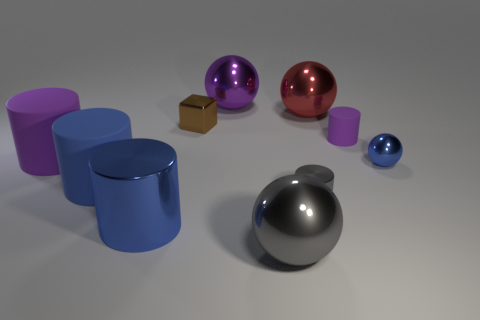Subtract all gray cylinders. How many cylinders are left? 4 Subtract all large shiny cylinders. How many cylinders are left? 4 Subtract all red cylinders. Subtract all red blocks. How many cylinders are left? 5 Subtract all cubes. How many objects are left? 9 Subtract all big gray metal spheres. Subtract all large gray objects. How many objects are left? 8 Add 2 purple objects. How many purple objects are left? 5 Add 1 blocks. How many blocks exist? 2 Subtract 1 blue cylinders. How many objects are left? 9 